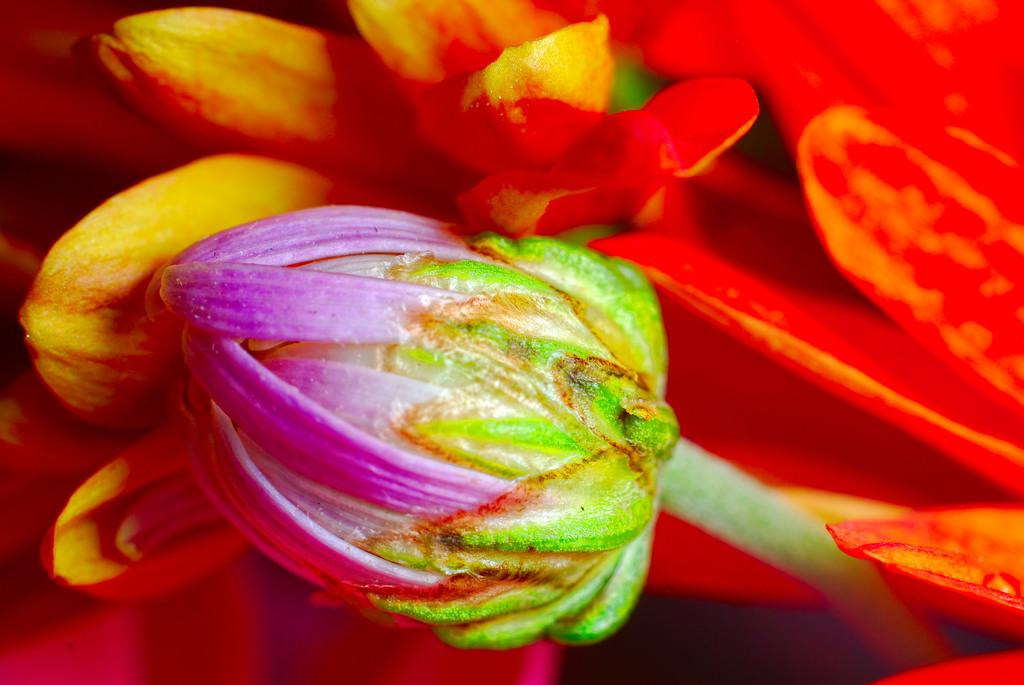What type of flowers can be seen in the image? There are orange color flowers in the image. Can you describe any other elements related to the flowers? There is a bud in the image. What colors are present in the bud? The bud is of purple and green color. What type of music can be heard coming from the club in the image? There is no club or music present in the image; it features orange color flowers and a purple and green bud. 